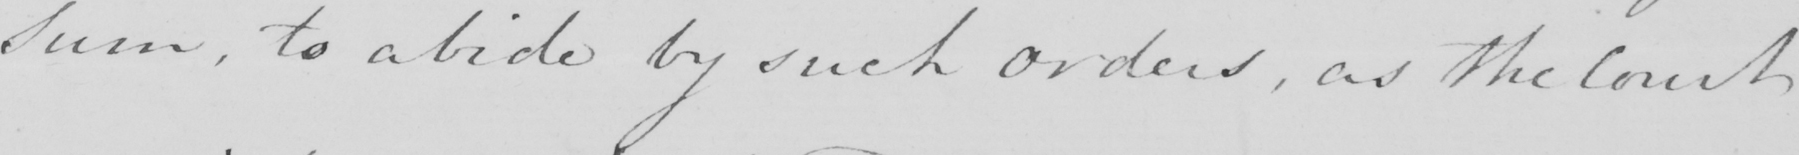Transcribe the text shown in this historical manuscript line. Sum , to abide by such orders , as the Court 